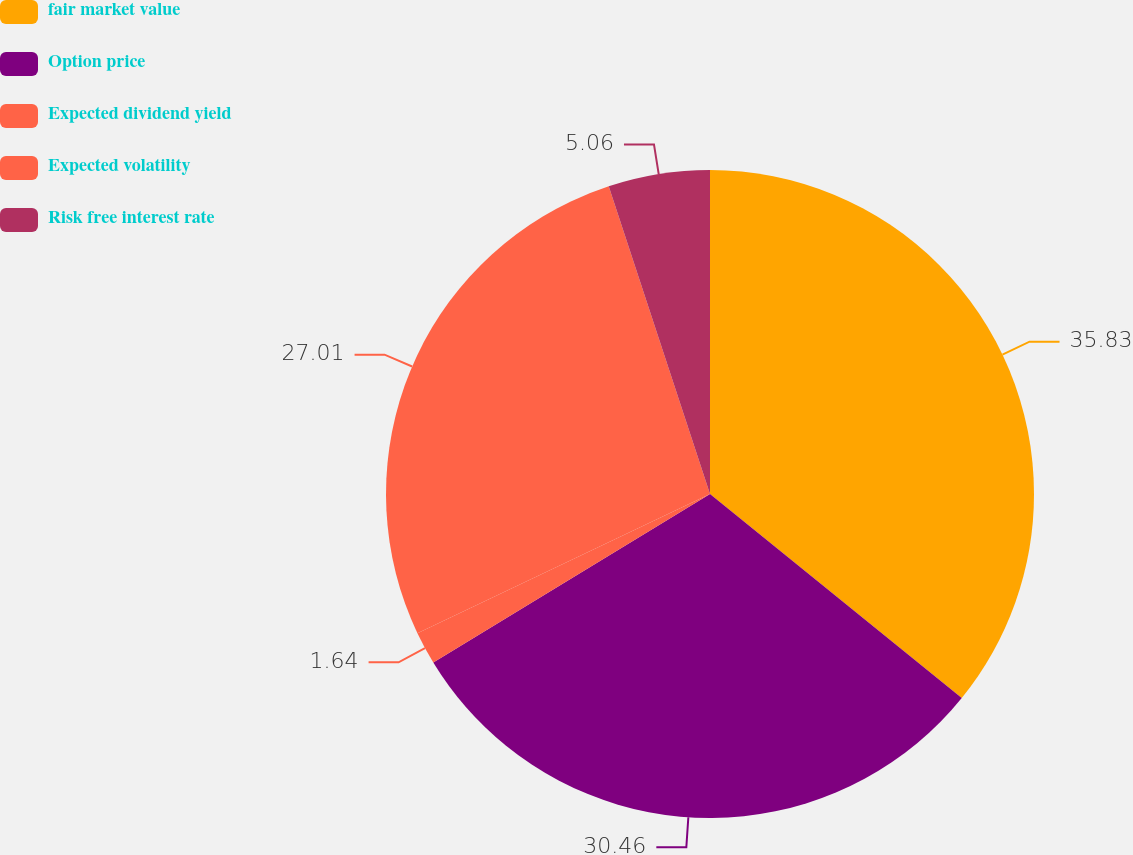Convert chart to OTSL. <chart><loc_0><loc_0><loc_500><loc_500><pie_chart><fcel>fair market value<fcel>Option price<fcel>Expected dividend yield<fcel>Expected volatility<fcel>Risk free interest rate<nl><fcel>35.84%<fcel>30.46%<fcel>1.64%<fcel>27.01%<fcel>5.06%<nl></chart> 